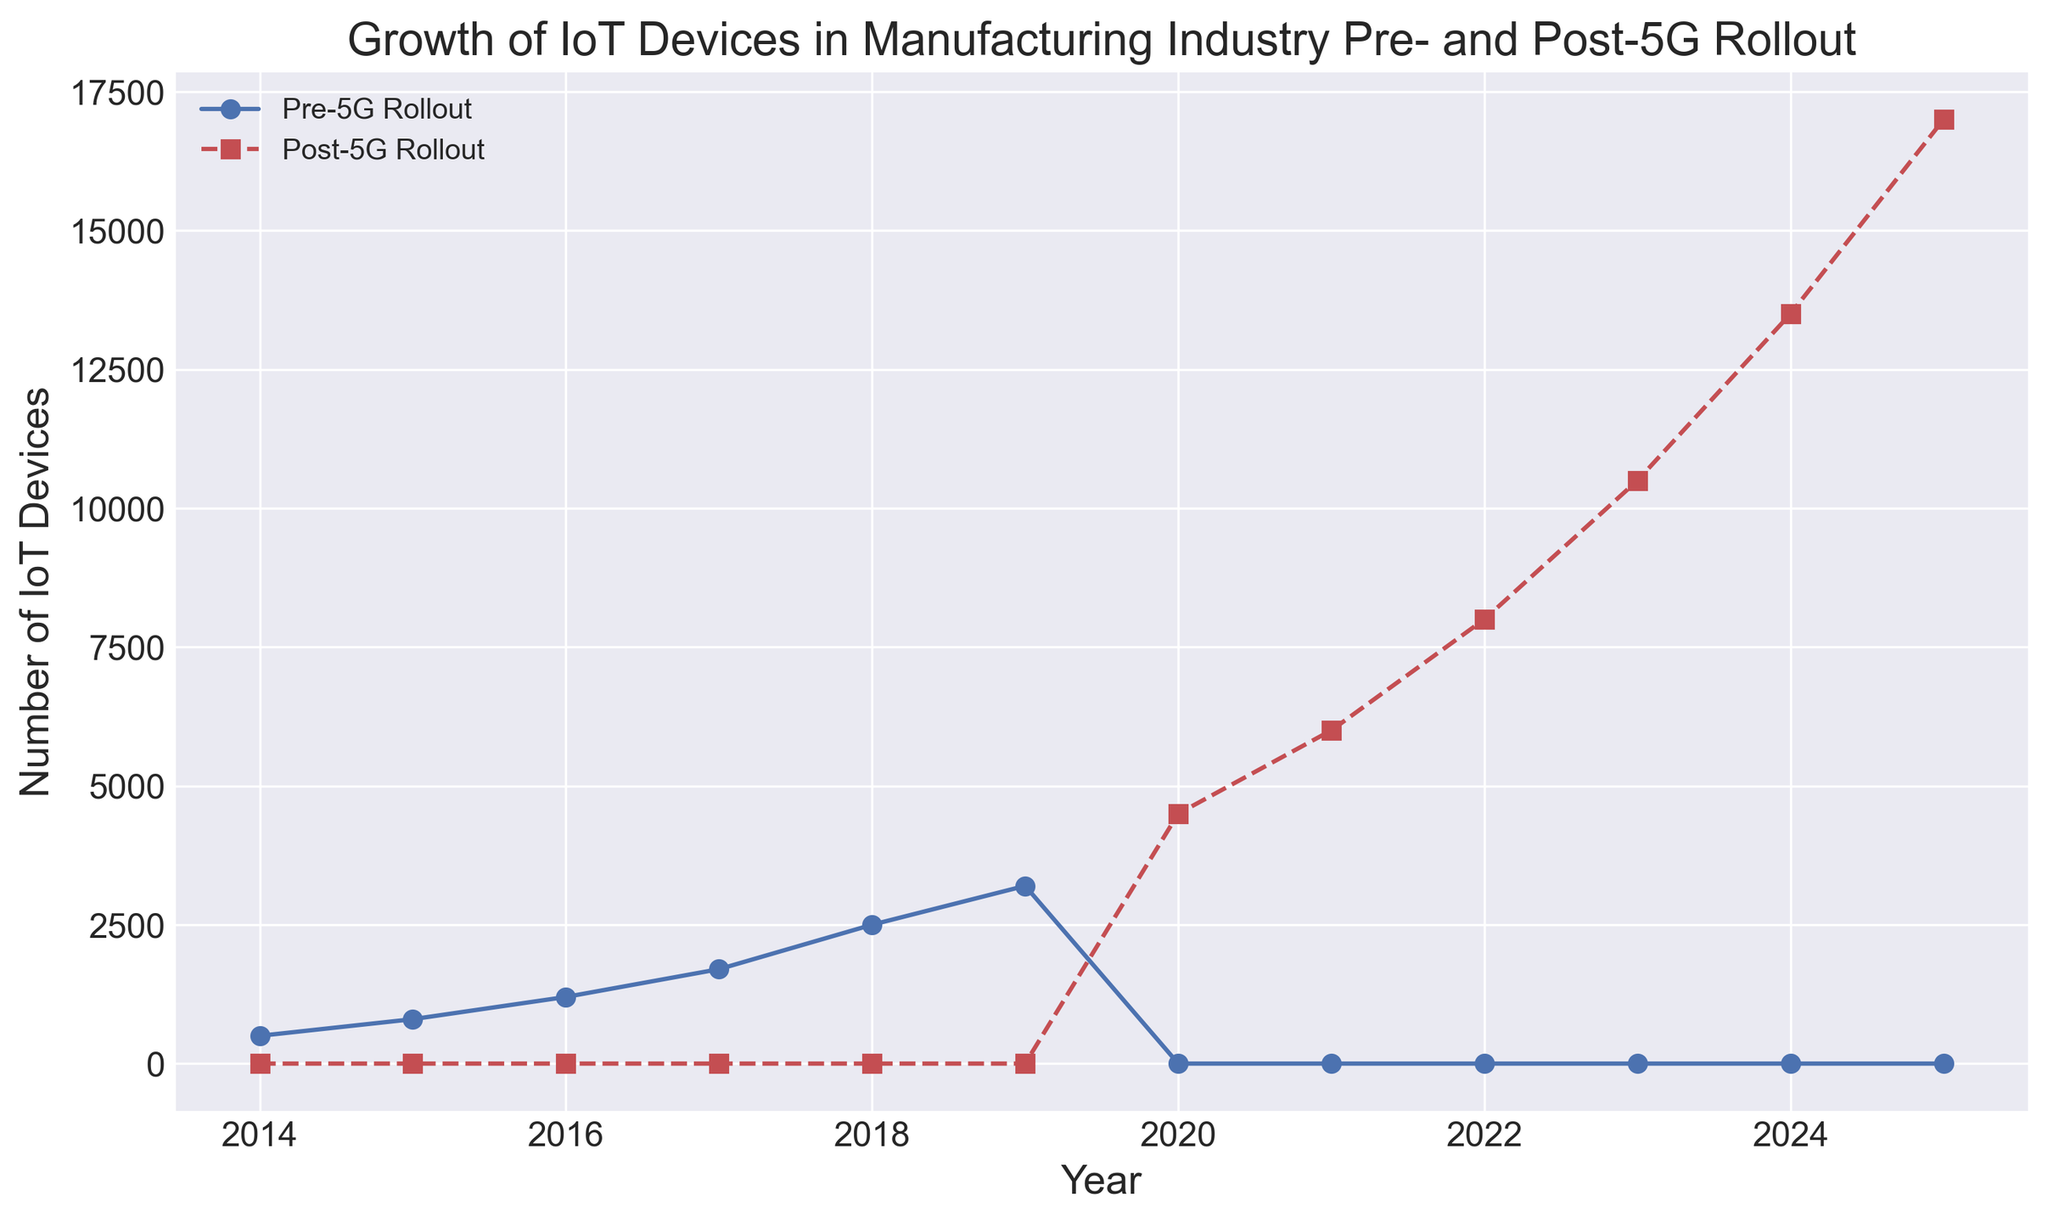What is the number of IoT devices in 2017 before the 5G rollout? The year 2017 corresponds to a blue line segment marked with an 'o'. The number of IoT devices is at the intersection of the y-axis corresponding to the year 2017.
Answer: 1700 What is the growth in the number of IoT devices from 2021 to 2023 after the 5G rollout? For the years 2021 and 2023, look at the number of IoT devices in the red dashed line marked with 's'. In 2021, the number is 6000, and in 2023, it is 10500. The growth is calculated as 10500 - 6000.
Answer: 4500 Compare the number of IoT devices in the final year before and after the 5G rollout. Which is higher and by how many? In the final year before the 5G rollout, 2019, there are 3200 IoT devices. In the final year after the 5G rollout, 2025, there are 17000 IoT devices. The difference is 17000 - 3200.
Answer: 13800 more How does the growth rate of IoT devices post-5G rollout (from 2020 to 2025) compare to the growth rate pre-5G rollout (from 2014 to 2019)? Growth rate pre-5G rollout: (3200 - 500) / (2019 - 2014) = 540 devices/year. Growth rate post-5G rollout: (17000 - 4500) / (2025 - 2020) = 2500 devices/year. The post-5G rollout growth rate is significantly higher.
Answer: Post-5G is higher (2500 devices/year vs. 540 devices/year) What trend do you notice in the number of IoT devices after the introduction of 5G? From 2020 onward, the number of IoT devices consistently increases each year, indicated by the steadily rising red dashed line with 's' markers.
Answer: Steadily increasing Determine the average number of IoT devices pre-5G rollout for the given years. Sum the number of IoT devices for the years 2014 to 2019 and divide by the number of years. (500 + 800 + 1200 + 1700 + 2500 + 3200) / 6 = 9900 / 6.
Answer: 1650 Identify the year where there was the largest single-year increase in IoT devices post-5G rollout. How many devices were added that year? To find the largest single-year increase post-5G, look at differences for each year. The largest is between 2024 and 2025: 17000 - 13500 = 3500 devices.
Answer: 2025, 3500 Which year witnessed the highest number of IoT devices post-5G rollout? The peak point on the red dashed line marked with 's' lies in the year 2025.
Answer: 2025 How does the number of IoT devices in 2018 compare to that in 2021? In 2018, the blue solid line with 'o' markers shows 2500 devices, while the red dashed line with 's' markers in 2021 shows 6000 devices. The number in 2021 is significantly higher.
Answer: 2021 is higher by 3500 